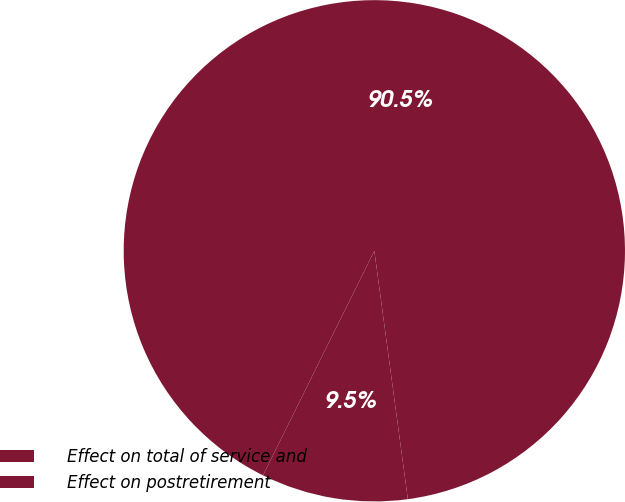<chart> <loc_0><loc_0><loc_500><loc_500><pie_chart><fcel>Effect on total of service and<fcel>Effect on postretirement<nl><fcel>9.46%<fcel>90.54%<nl></chart> 